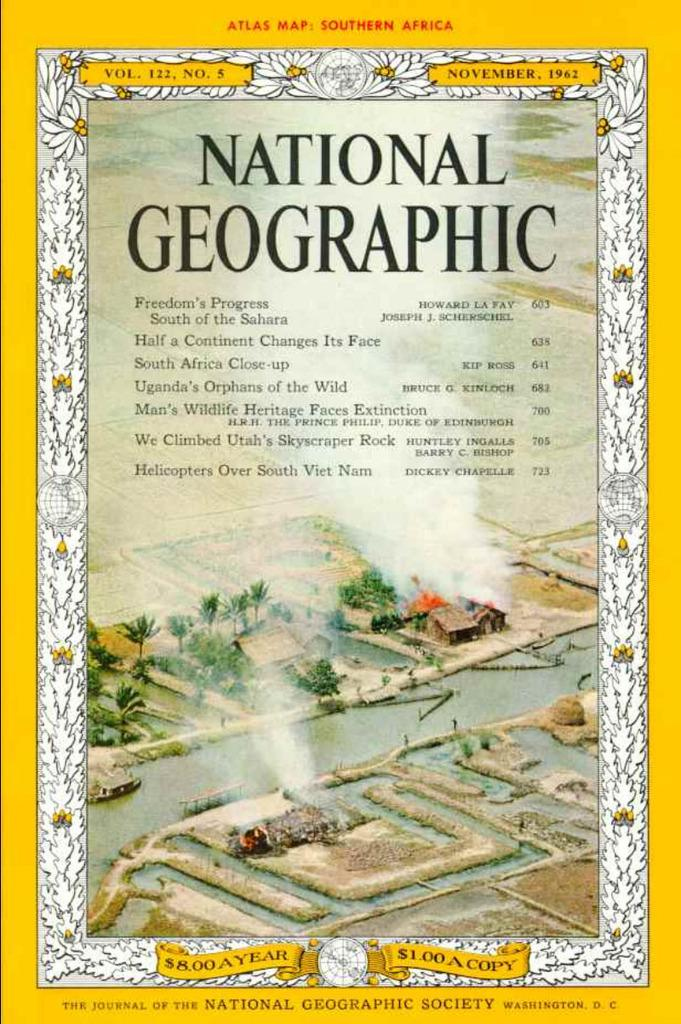<image>
Create a compact narrative representing the image presented. The cover of a National Geographic magazine from 1962. 